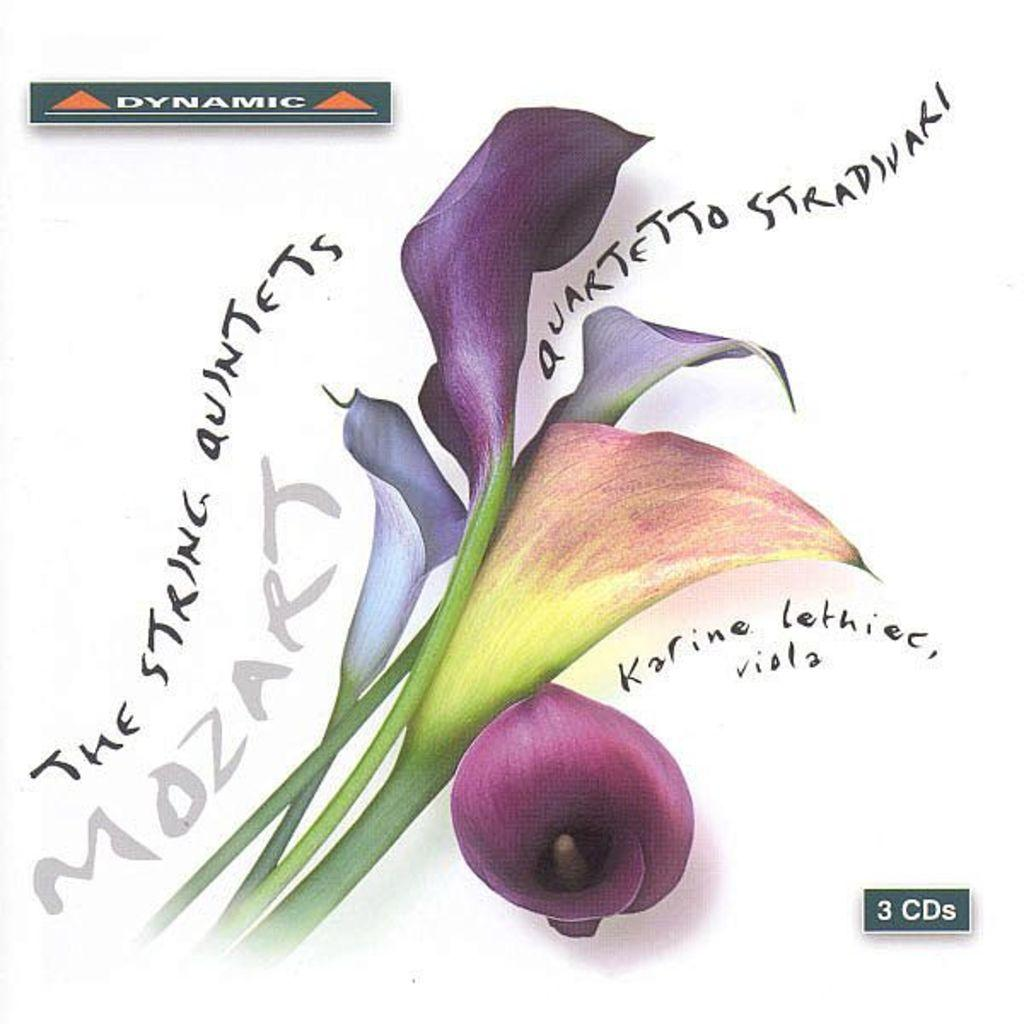What type of image is being described? The image is graphical in nature. What natural elements can be seen in the image? There are leaves depicted in the image. Are there any textual elements in the image? Yes, there is writing present in the image. Is there a cellar visible in the image? There is no mention of a cellar in the provided facts, and therefore it cannot be determined if one is present in the image. 